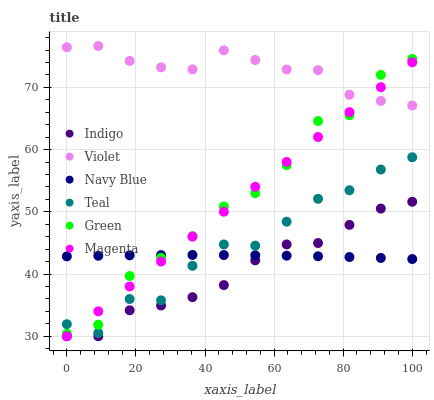Does Indigo have the minimum area under the curve?
Answer yes or no. Yes. Does Violet have the maximum area under the curve?
Answer yes or no. Yes. Does Navy Blue have the minimum area under the curve?
Answer yes or no. No. Does Navy Blue have the maximum area under the curve?
Answer yes or no. No. Is Magenta the smoothest?
Answer yes or no. Yes. Is Green the roughest?
Answer yes or no. Yes. Is Navy Blue the smoothest?
Answer yes or no. No. Is Navy Blue the roughest?
Answer yes or no. No. Does Indigo have the lowest value?
Answer yes or no. Yes. Does Navy Blue have the lowest value?
Answer yes or no. No. Does Violet have the highest value?
Answer yes or no. Yes. Does Green have the highest value?
Answer yes or no. No. Is Indigo less than Teal?
Answer yes or no. Yes. Is Violet greater than Indigo?
Answer yes or no. Yes. Does Green intersect Magenta?
Answer yes or no. Yes. Is Green less than Magenta?
Answer yes or no. No. Is Green greater than Magenta?
Answer yes or no. No. Does Indigo intersect Teal?
Answer yes or no. No. 